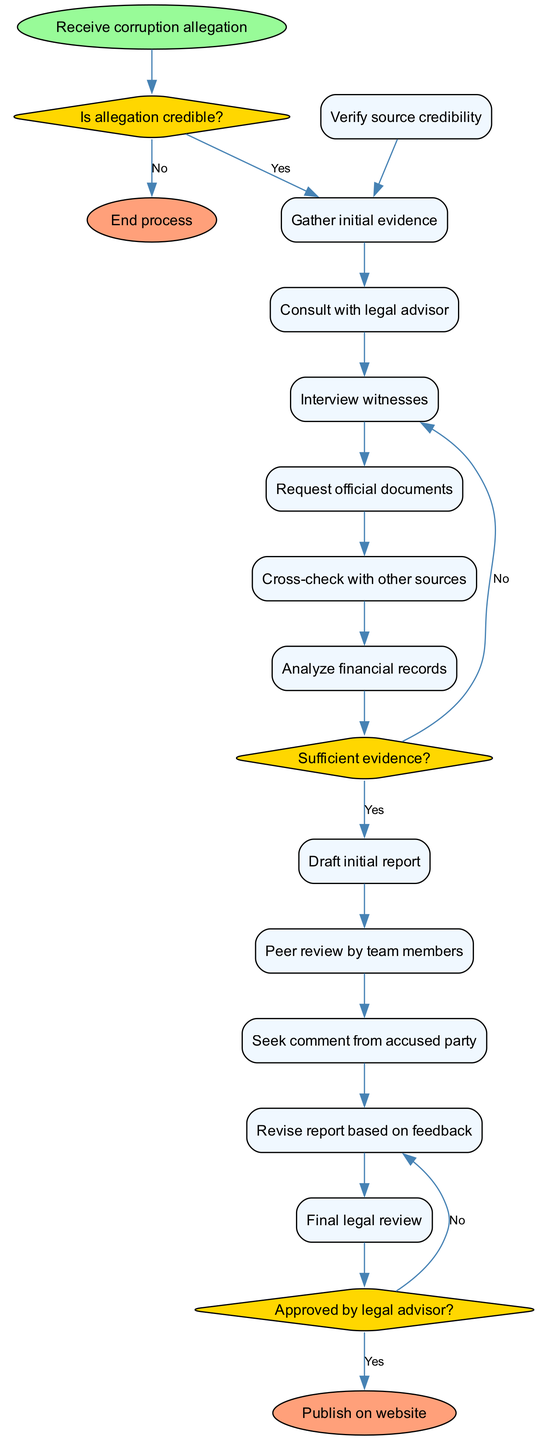What is the starting point of the workflow? The starting point of the workflow is indicated as "Receive corruption allegation". This node is marked as the first step in the process and leads to the first decision.
Answer: Receive corruption allegation How many activities are listed in the diagram? By counting the nodes under the "activities" section, there are a total of 10 activities. These activities are steps in the fact-checking workflow that follows the initial decision.
Answer: 10 What decision follows the verification of source credibility? The decision that follows verifying source credibility is "Is allegation credible?". This question determines the next course of action based on the credibility of the allegation.
Answer: Is allegation credible? If the answer to "Is allegation credible?" is "Yes", what’s the next step? If the answer to "Is allegation credible?" is "Yes", the next step is "Gather initial evidence". This activity is crucial as it builds the foundation for further actions based on the credibility of the allegation.
Answer: Gather initial evidence What happens if the evidence gathered is insufficient? If the evidence gathered is insufficient, based on the decision "Sufficient evidence?", the workflow indicates that the next action is to "Gather more evidence". This shows that the process is iterative and aims for thoroughness before drafting a report.
Answer: Gather more evidence What is the outcome if the final legal review is approved? If the final legal review is approved, the outcome is to "Publish on website". This indicates that the fact-checking process has reached a satisfactory conclusion that meets legal standards.
Answer: Publish on website What is the last activity before seeking comment from the accused party? The last activity before seeking comment from the accused party is "Revised report based on feedback". This step shows that the team values input and ensures the report is accurate before proceeding.
Answer: Revised report based on feedback Which decision must be approved to conclude the workflow with a publication? The decision that must be approved to conclude the workflow with a publication is "Approved by legal advisor?". This step is critical in ensuring that the report adheres to legal standards before being made public.
Answer: Approved by legal advisor? 